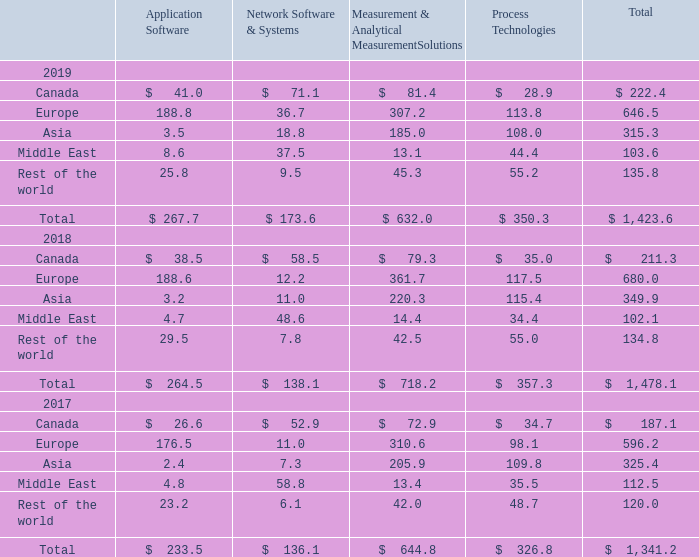Export sales from the U.S. during the years ended December 31, 2019, 2018 and 2017 were $531.8, $578.0 and $512.5, respectively. In the year ended December 31, 2019, these exports were shipped primarily to Asia (33%), Europe (24%), Canada (18%), Middle East (13%) and other (12%).
Sales to customers outside the U.S. accounted for a significant portion of Roper’s revenues. Sales are attributed to geographic areas based upon the location where the product is ultimately shipped. Roper’s net revenues for the years ended December 31, 2019, 2018 and 2017 are shown below by region, except for Canada, which is presented separately as it is the only country in which Roper has had greater than 4% of total revenues for any of the three years presented:
What are the proportions of export sales from the U.S. to Asia and Europe, respectively?  33%, 24%. What is the total net revenue from Canada in 2019? $ 222.4. What is the total net revenue from the rest of the world in 2017? 120.0. What is the percentage change in net revenue from the Middle East in 2019 compared to 2018?
Answer scale should be: percent. (103.6-102.1)/102.1 
Answer: 1.47. What is the proportion of net revenue from Europe and Asia over total net revenue in 2017? (596.2 +325.4)/1,341.2 
Answer: 0.69. What is the ratio of net revenue from the Application Software segment to the Process Technologies segment in 2018? 264.5/357.3 
Answer: 0.74. 